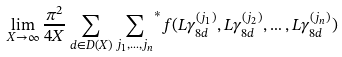Convert formula to latex. <formula><loc_0><loc_0><loc_500><loc_500>\lim _ { X \rightarrow \infty } \frac { \pi ^ { 2 } } { 4 X } \sum _ { d \in D ( X ) } { \sum _ { j _ { 1 } , \dots , j _ { n } } } ^ { * } f ( L \gamma ^ { ( j _ { 1 } ) } _ { 8 d } , L \gamma ^ { ( j _ { 2 } ) } _ { 8 d } , \dots , L \gamma ^ { ( j _ { n } ) } _ { 8 d } )</formula> 